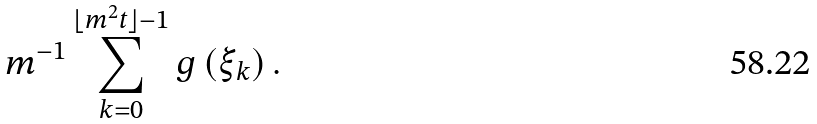<formula> <loc_0><loc_0><loc_500><loc_500>m ^ { - 1 } \sum _ { k = 0 } ^ { \lfloor m ^ { 2 } t \rfloor - 1 } g \left ( \xi _ { k } \right ) .</formula> 